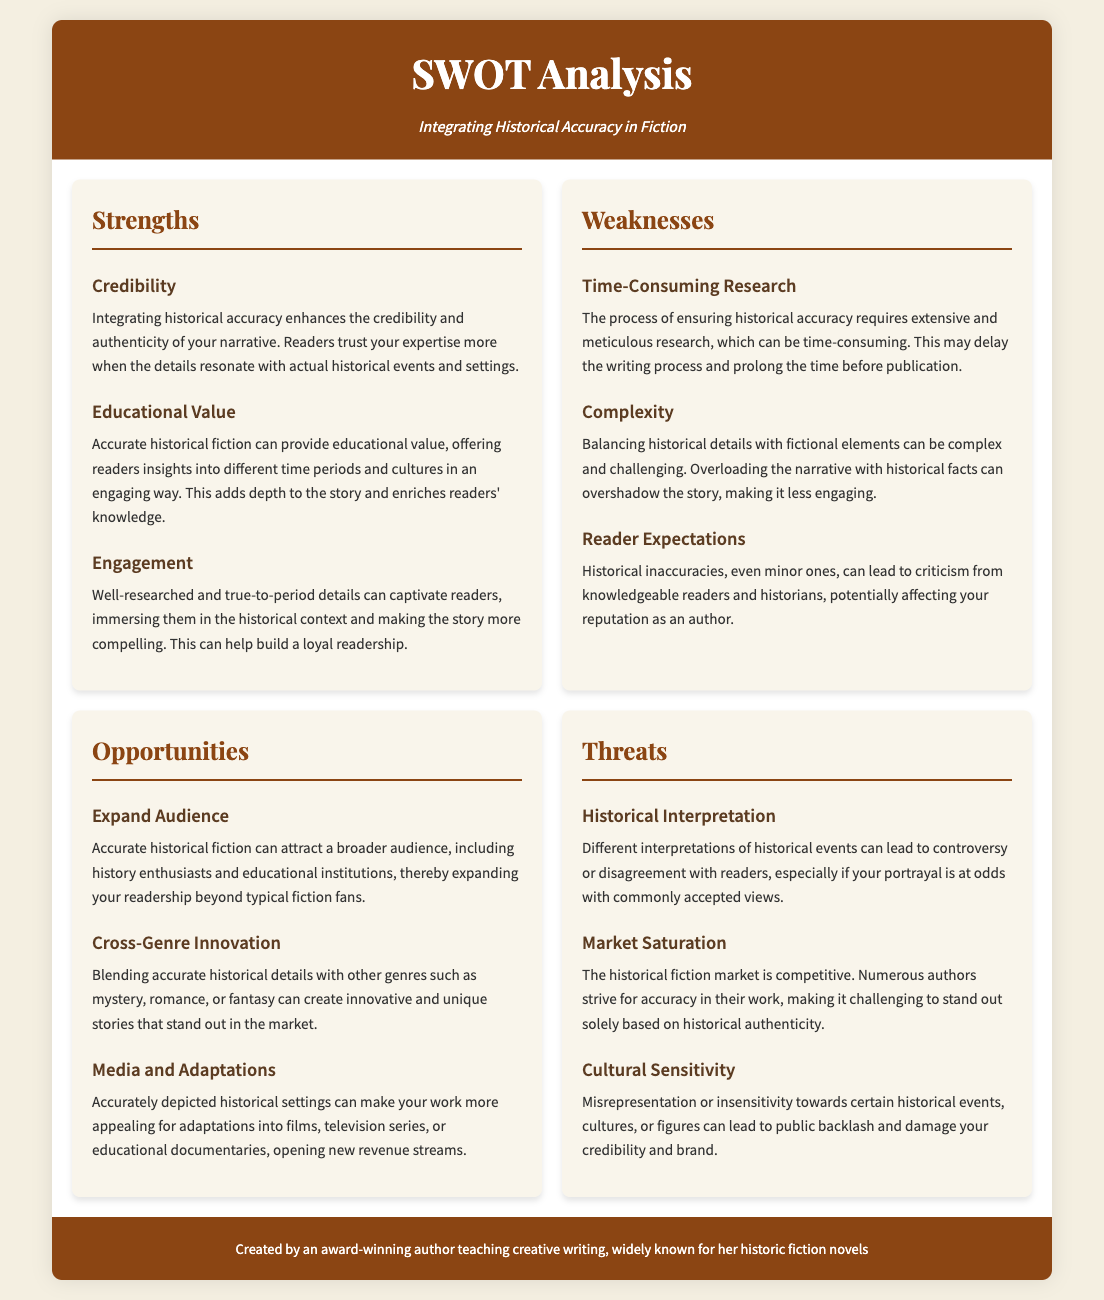What are the strengths of integrating historical accuracy? The strengths include credibility, educational value, and engagement as outlined in the SWOT analysis.
Answer: credibility, educational value, engagement What is a weakness related to the research process? One of the weaknesses highlights the time-consuming nature of ensuring historical accuracy through extensive research.
Answer: Time-Consuming Research What opportunity can arise from accurate historical fiction? The analysis mentions the potential to expand the audience as a key opportunity for authors.
Answer: Expand Audience What threat involves reader opinions on historical events? The document discusses the issue of historical interpretation as a threat regarding reader responses.
Answer: Historical Interpretation How many areas are covered in the SWOT analysis? The SWOT analysis covers four main areas: strengths, weaknesses, opportunities, and threats.
Answer: Four What is suggested as a way to attract a broader audience? The opportunity for accurate historical fiction is to attract history enthusiasts and educational institutions.
Answer: history enthusiasts and educational institutions What could be a reason for public backlash? The document mentions cultural sensitivity as a potential cause for public backlash due to misrepresentation.
Answer: Misrepresentation What is a potential benefit of media adaptations according to the analysis? The SWOT analysis indicates that accurately depicted historical settings can enhance appeal for adaptations.
Answer: appeal for adaptations 